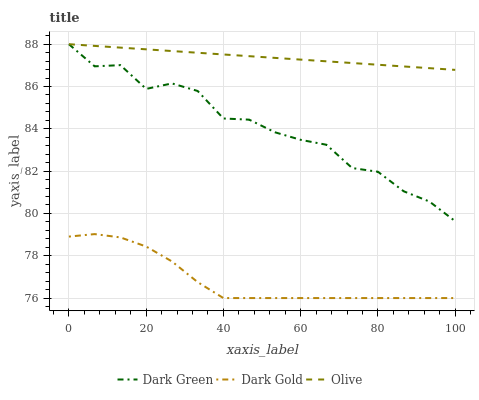Does Dark Gold have the minimum area under the curve?
Answer yes or no. Yes. Does Olive have the maximum area under the curve?
Answer yes or no. Yes. Does Dark Green have the minimum area under the curve?
Answer yes or no. No. Does Dark Green have the maximum area under the curve?
Answer yes or no. No. Is Olive the smoothest?
Answer yes or no. Yes. Is Dark Green the roughest?
Answer yes or no. Yes. Is Dark Gold the smoothest?
Answer yes or no. No. Is Dark Gold the roughest?
Answer yes or no. No. Does Dark Gold have the lowest value?
Answer yes or no. Yes. Does Dark Green have the lowest value?
Answer yes or no. No. Does Dark Green have the highest value?
Answer yes or no. Yes. Does Dark Gold have the highest value?
Answer yes or no. No. Is Dark Gold less than Olive?
Answer yes or no. Yes. Is Dark Green greater than Dark Gold?
Answer yes or no. Yes. Does Dark Green intersect Olive?
Answer yes or no. Yes. Is Dark Green less than Olive?
Answer yes or no. No. Is Dark Green greater than Olive?
Answer yes or no. No. Does Dark Gold intersect Olive?
Answer yes or no. No. 